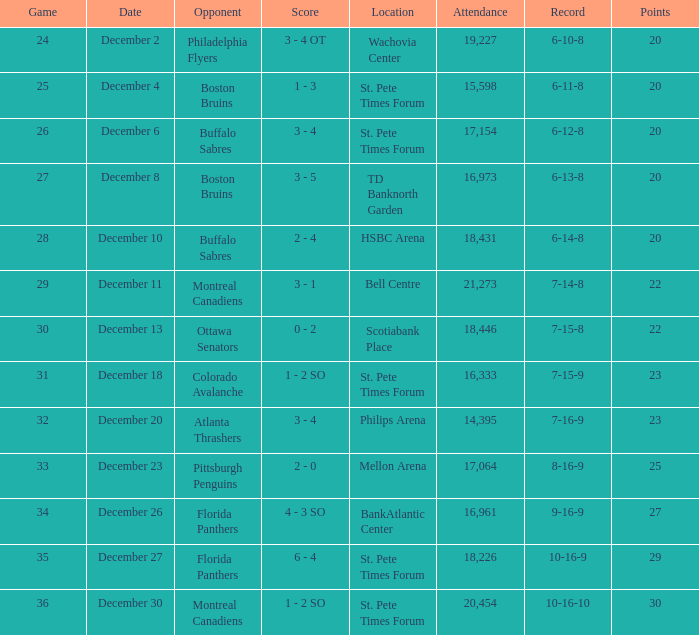What is the place of the game with a 6-11-8 record? St. Pete Times Forum. 